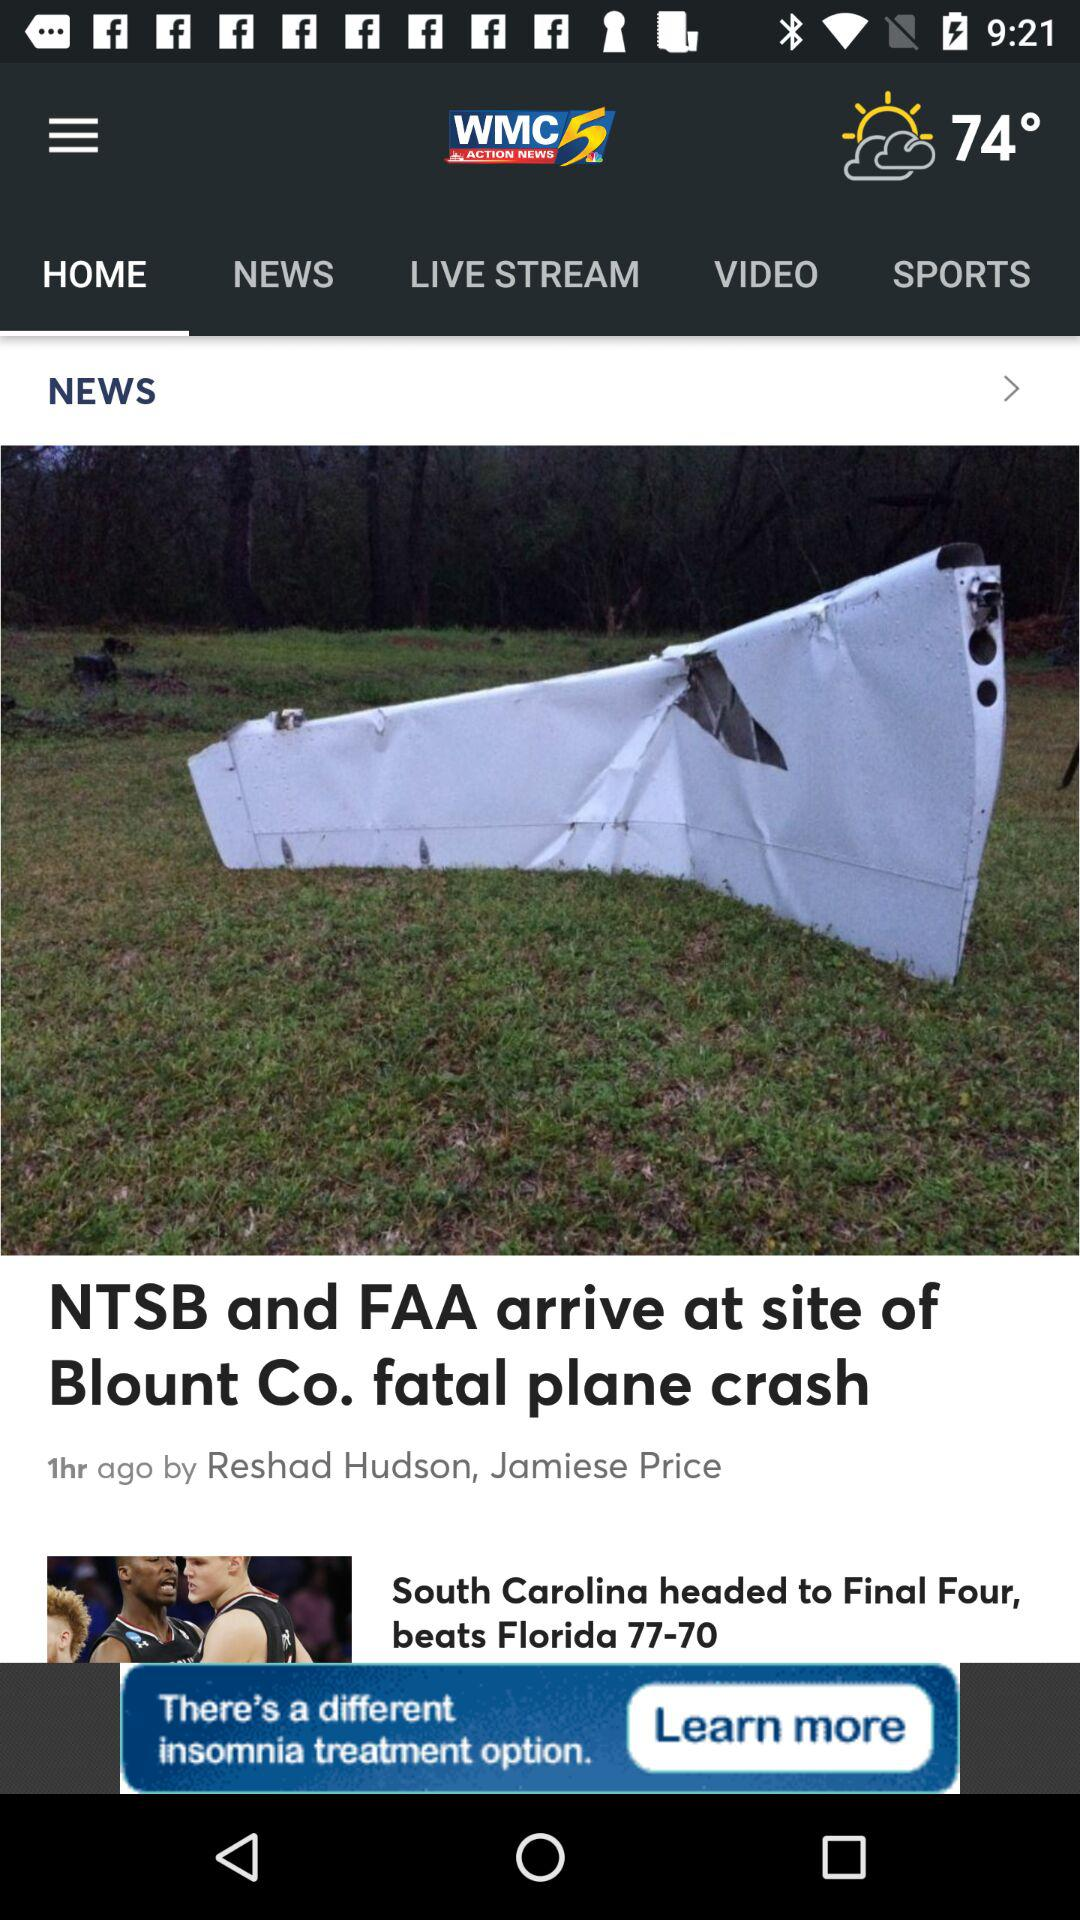Which tab is selected? The selected tab is "HOME". 